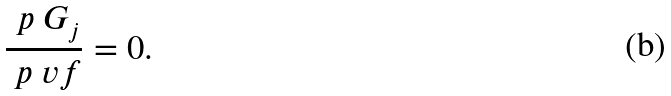Convert formula to latex. <formula><loc_0><loc_0><loc_500><loc_500>\frac { \ p \ G _ { j } } { \ p \ v f } = 0 .</formula> 